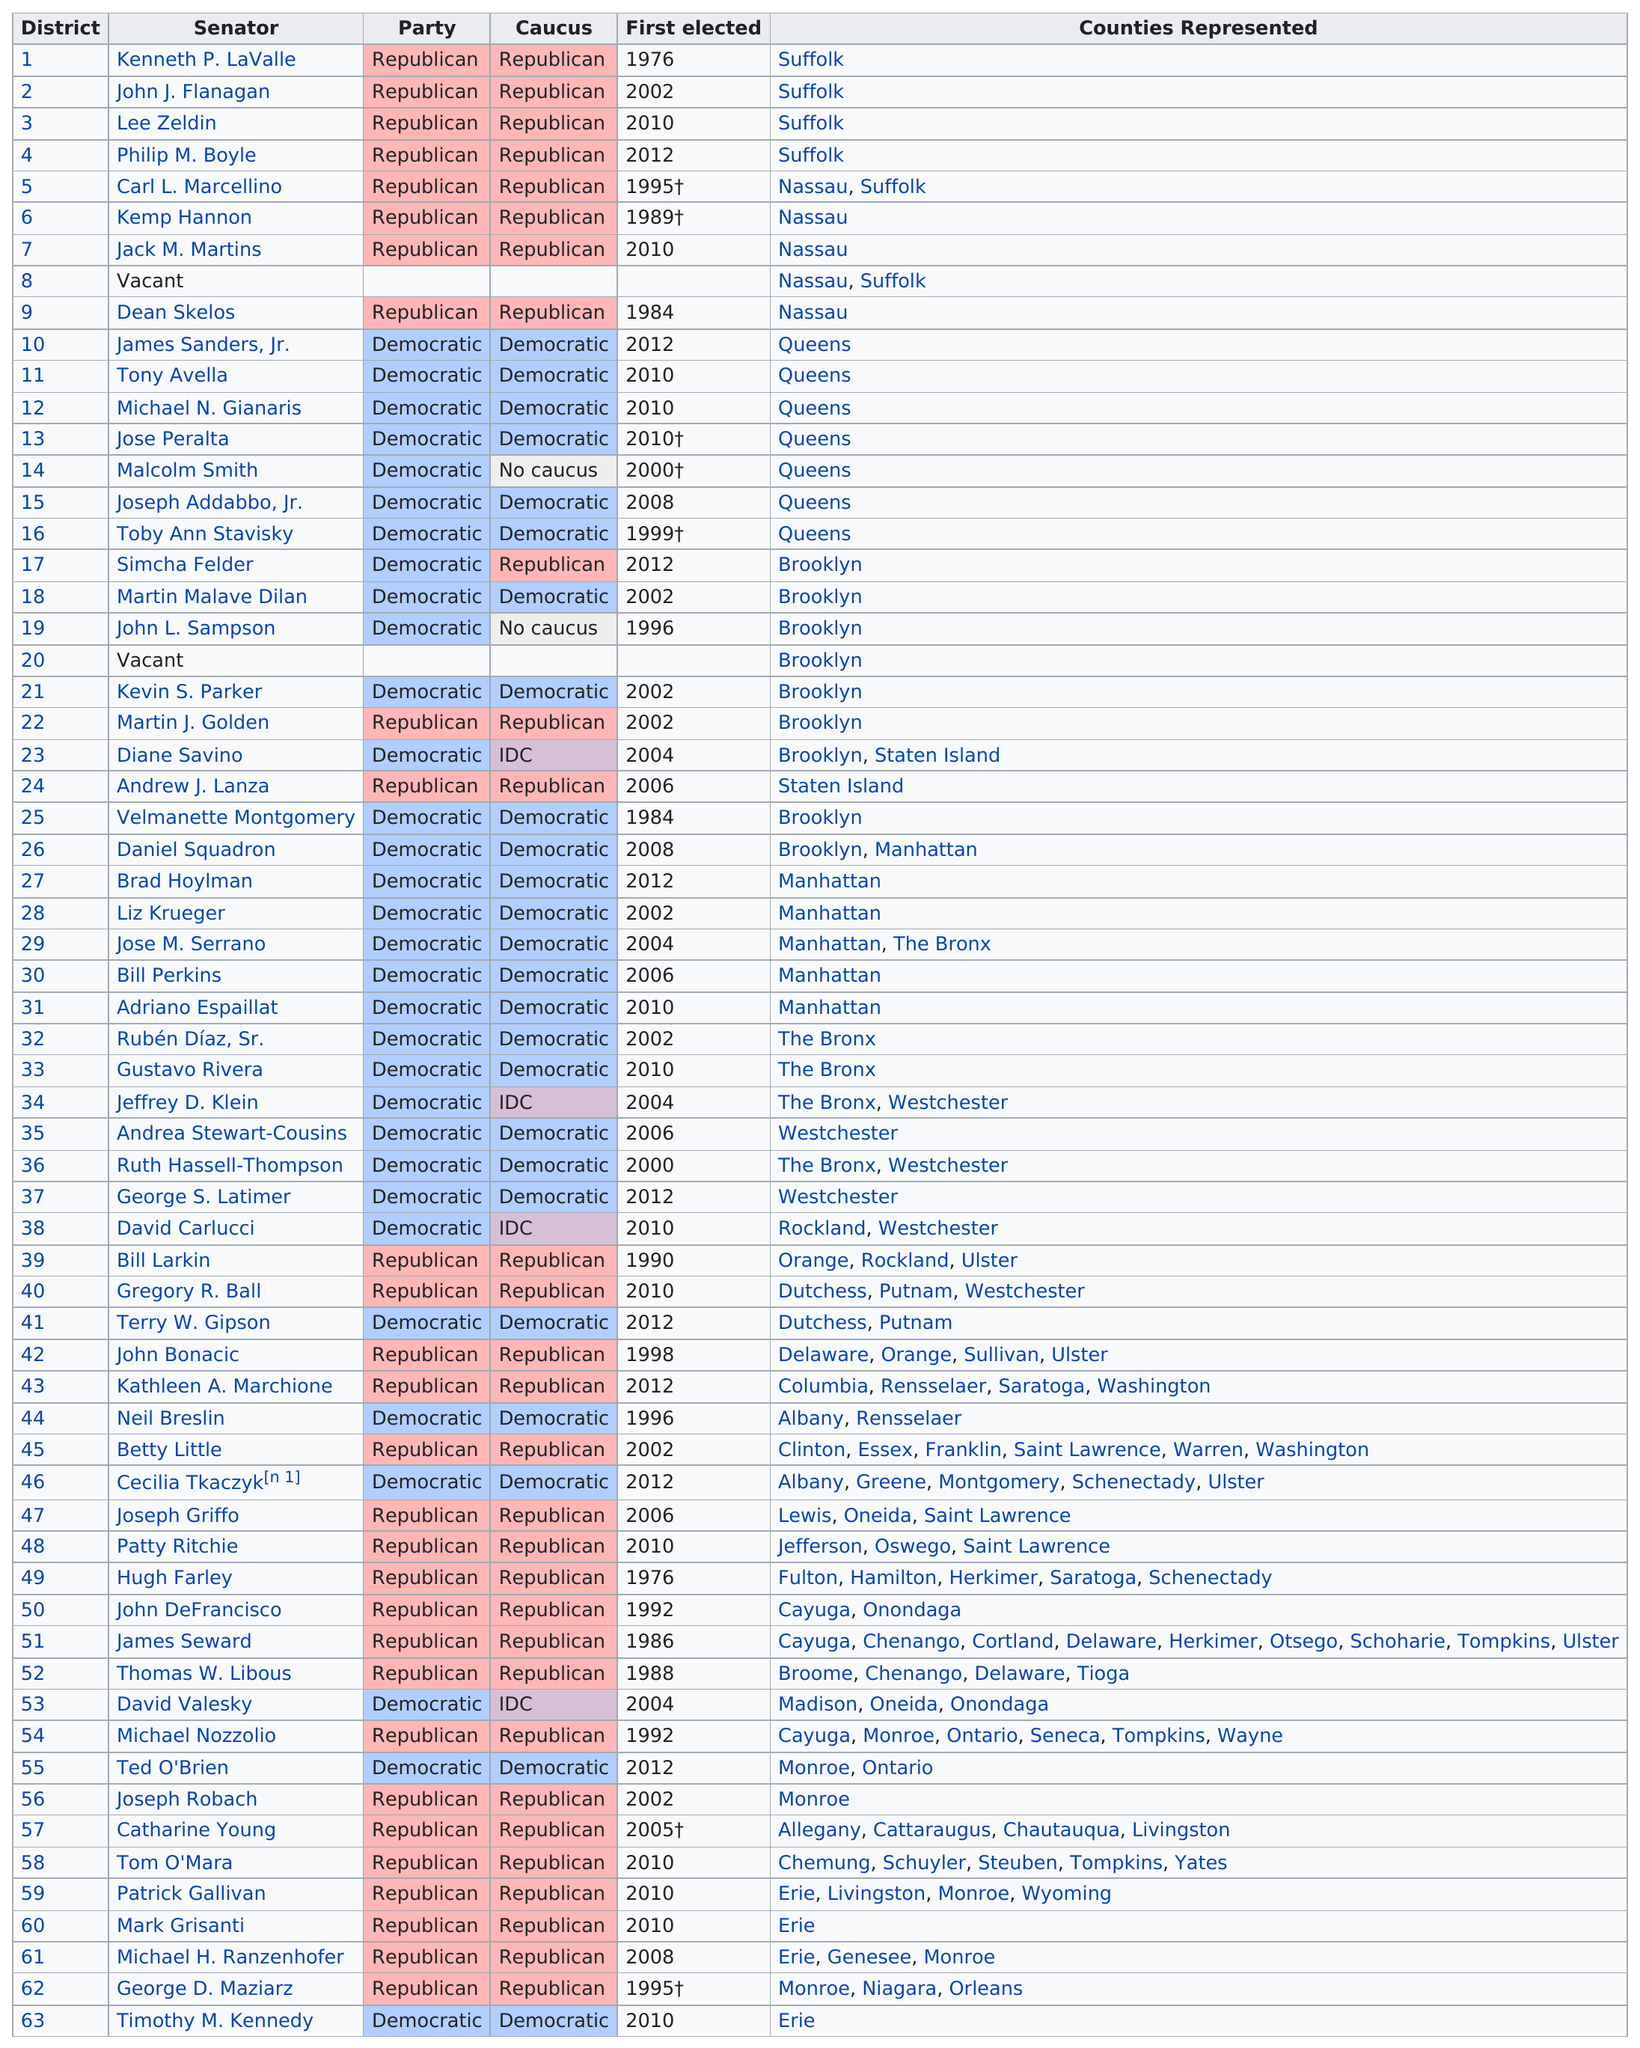Mention a couple of crucial points in this snapshot. According to my knowledge, two state senators currently do not belong to any caucus. I have only met one state senator who caucuses with the IDC and whose last name ends in 'v', and that senator is David Valesky. At least five Democrats from Brooklyn have been elected. Out of all the counties, none have elected more than 10 Democrats. Out of the total number of senators from Suffolk, 6 were elected. 